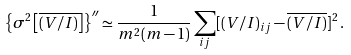Convert formula to latex. <formula><loc_0><loc_0><loc_500><loc_500>\left \{ \sigma ^ { 2 } \left [ \overline { ( V / I ) } \right ] \right \} ^ { \prime \prime } \simeq \frac { 1 } { m ^ { 2 } ( m - 1 ) } \sum _ { i j } [ ( V / I ) _ { i j } - \overline { ( V / I ) } ] ^ { 2 } \, .</formula> 